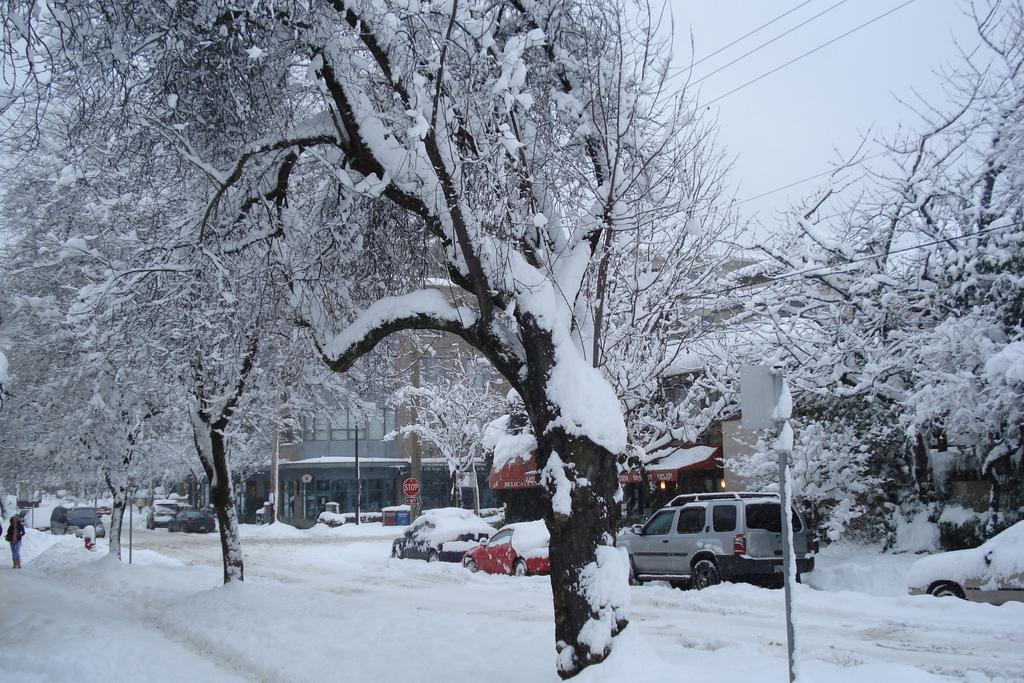Describe this image in one or two sentences. In the picture I can see the snow fall where roads, trees, vehicles and buildings are covered with snow, we can see boards, few people standing on the left side of the image, I can see the wires and the sky in the background. 